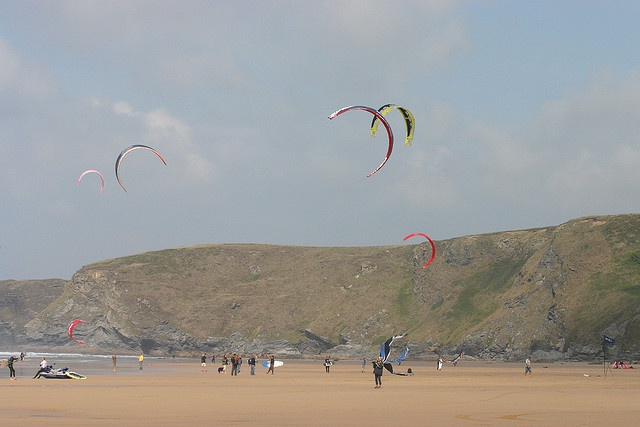Describe the objects in this image and their specific colors. I can see people in darkgray, tan, and gray tones, kite in darkgray, olive, and black tones, kite in darkgray, maroon, gray, and lightgray tones, kite in darkgray, lightgray, lightpink, and brown tones, and kite in darkgray, black, gray, and tan tones in this image. 